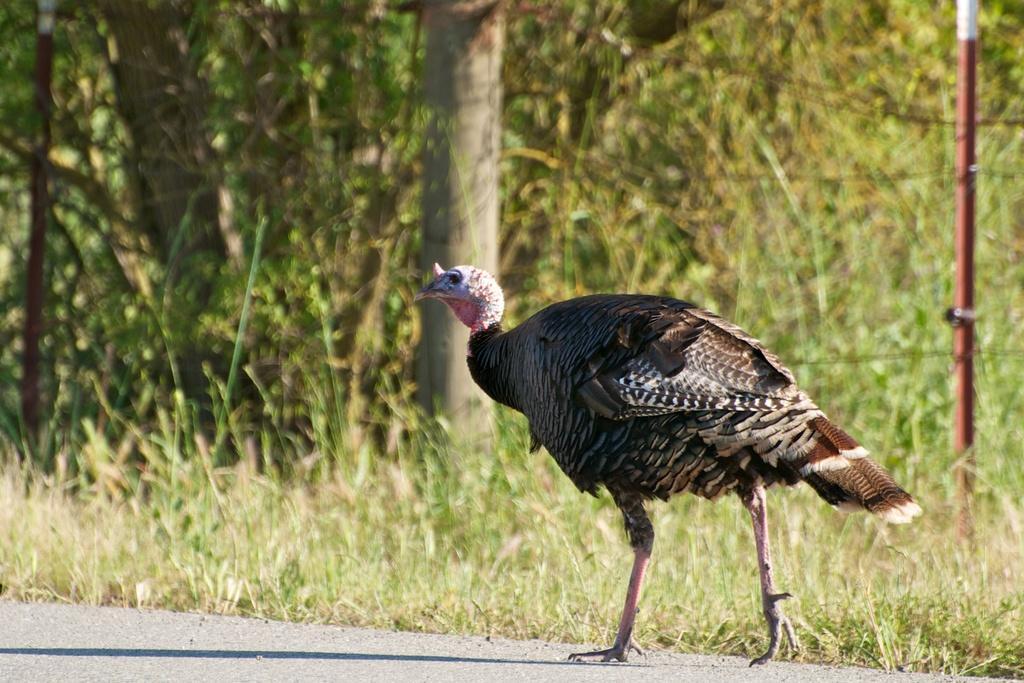Describe this image in one or two sentences. In the picture we can see the bird on the part of the road surface and beside it we can see grass surface and trees and we can see two poles on the either sides. 